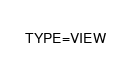Convert code to text. <code><loc_0><loc_0><loc_500><loc_500><_VisualBasic_>TYPE=VIEW</code> 